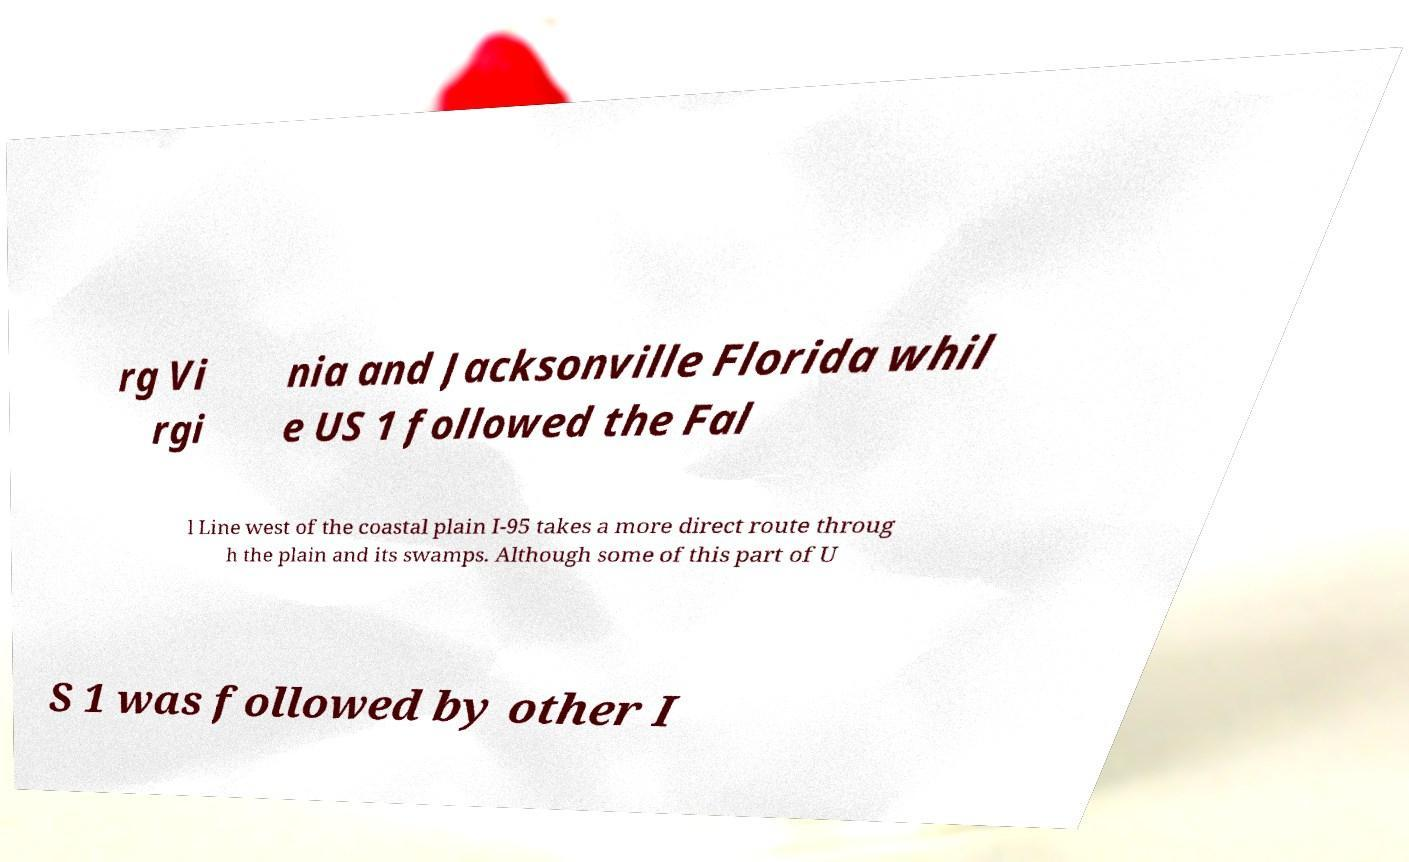Could you assist in decoding the text presented in this image and type it out clearly? rg Vi rgi nia and Jacksonville Florida whil e US 1 followed the Fal l Line west of the coastal plain I-95 takes a more direct route throug h the plain and its swamps. Although some of this part of U S 1 was followed by other I 